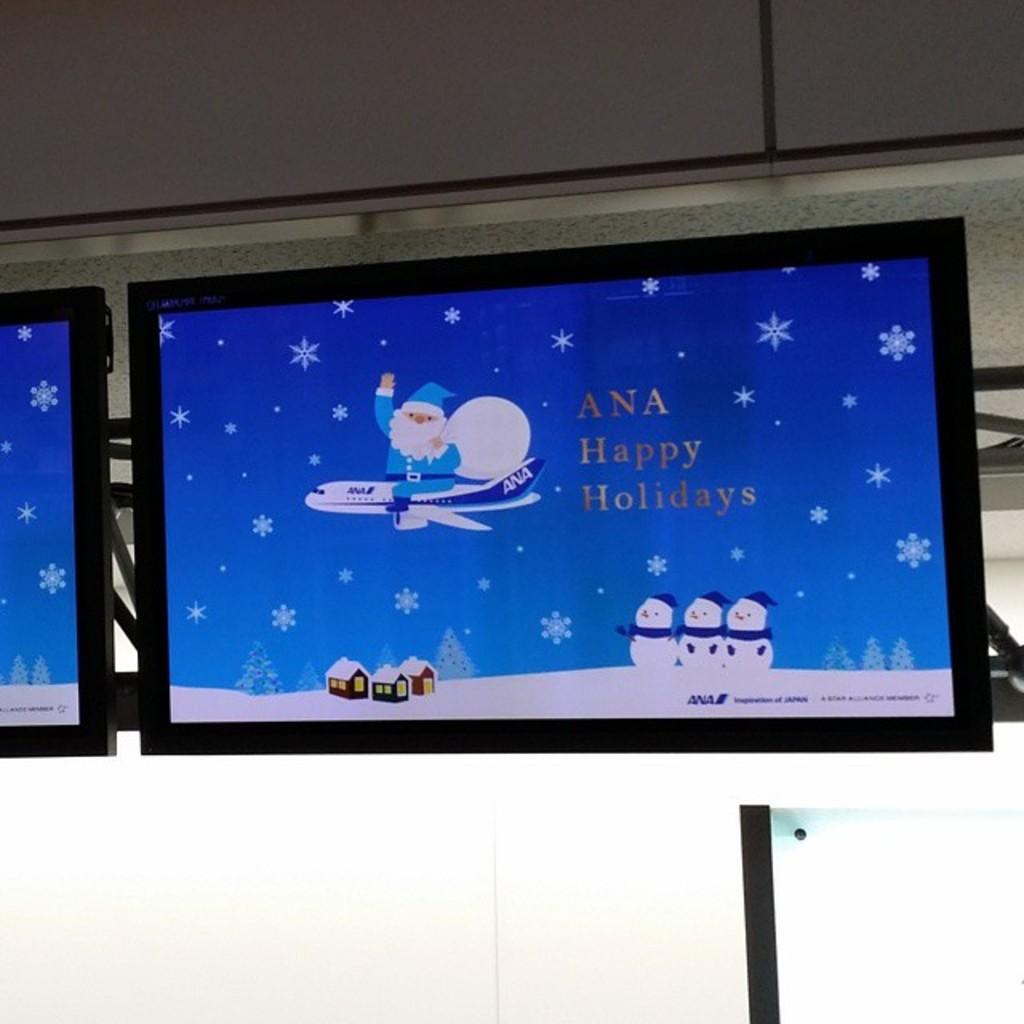What does the background say?
Make the answer very short. Ana happy holidays. 